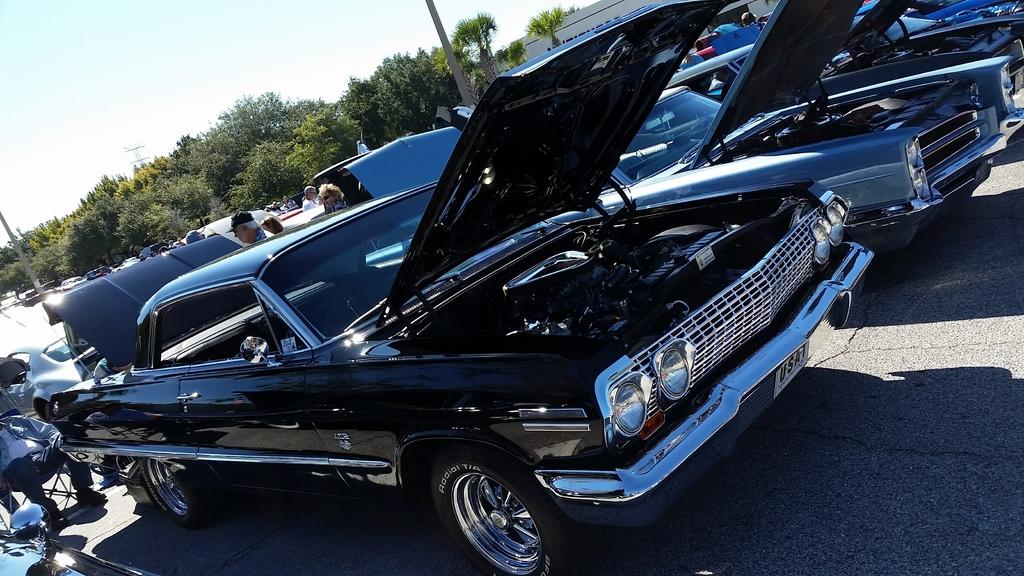What is the position of the car bonnets in the image? The car bonnets are opened in the image. How are the cars positioned in the image? The cars are parked in the image. What can be seen in the background of the image? There are people, trees, a building, a tower, and the sky visible in the background of the image. What type of mist is covering the cars in the image? There is no mist present in the image; the cars are parked with their bonnets opened. What idea is being conveyed by the people standing in the background of the image? The image does not convey any specific idea or message; it simply shows cars with opened bonnets and people standing in the background. 